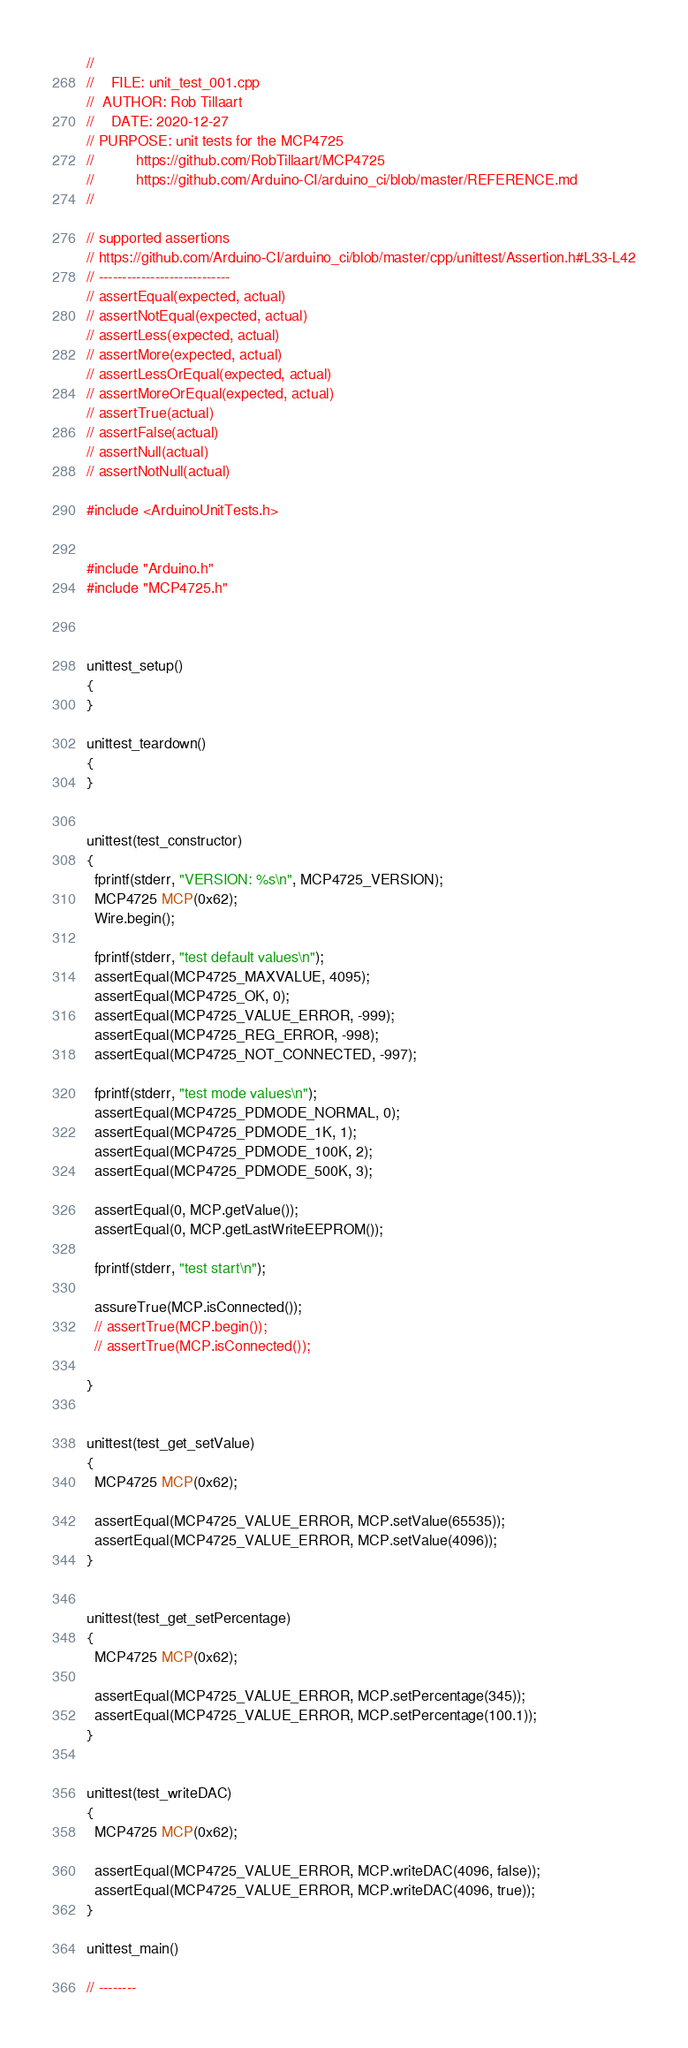Convert code to text. <code><loc_0><loc_0><loc_500><loc_500><_C++_>//
//    FILE: unit_test_001.cpp
//  AUTHOR: Rob Tillaart
//    DATE: 2020-12-27
// PURPOSE: unit tests for the MCP4725
//          https://github.com/RobTillaart/MCP4725
//          https://github.com/Arduino-CI/arduino_ci/blob/master/REFERENCE.md
//

// supported assertions
// https://github.com/Arduino-CI/arduino_ci/blob/master/cpp/unittest/Assertion.h#L33-L42
// ----------------------------
// assertEqual(expected, actual)
// assertNotEqual(expected, actual)
// assertLess(expected, actual)
// assertMore(expected, actual)
// assertLessOrEqual(expected, actual)
// assertMoreOrEqual(expected, actual)
// assertTrue(actual)
// assertFalse(actual)
// assertNull(actual)
// assertNotNull(actual)

#include <ArduinoUnitTests.h>


#include "Arduino.h"
#include "MCP4725.h"



unittest_setup()
{
}

unittest_teardown()
{
}


unittest(test_constructor)
{
  fprintf(stderr, "VERSION: %s\n", MCP4725_VERSION);
  MCP4725 MCP(0x62);
  Wire.begin();

  fprintf(stderr, "test default values\n");
  assertEqual(MCP4725_MAXVALUE, 4095);
  assertEqual(MCP4725_OK, 0);
  assertEqual(MCP4725_VALUE_ERROR, -999);
  assertEqual(MCP4725_REG_ERROR, -998);
  assertEqual(MCP4725_NOT_CONNECTED, -997);

  fprintf(stderr, "test mode values\n");
  assertEqual(MCP4725_PDMODE_NORMAL, 0);
  assertEqual(MCP4725_PDMODE_1K, 1);
  assertEqual(MCP4725_PDMODE_100K, 2);
  assertEqual(MCP4725_PDMODE_500K, 3);

  assertEqual(0, MCP.getValue());
  assertEqual(0, MCP.getLastWriteEEPROM());

  fprintf(stderr, "test start\n");

  assureTrue(MCP.isConnected());
  // assertTrue(MCP.begin());
  // assertTrue(MCP.isConnected());

}


unittest(test_get_setValue)
{
  MCP4725 MCP(0x62);

  assertEqual(MCP4725_VALUE_ERROR, MCP.setValue(65535));
  assertEqual(MCP4725_VALUE_ERROR, MCP.setValue(4096));
}


unittest(test_get_setPercentage)
{
  MCP4725 MCP(0x62);

  assertEqual(MCP4725_VALUE_ERROR, MCP.setPercentage(345));
  assertEqual(MCP4725_VALUE_ERROR, MCP.setPercentage(100.1));
}


unittest(test_writeDAC)
{
  MCP4725 MCP(0x62);

  assertEqual(MCP4725_VALUE_ERROR, MCP.writeDAC(4096, false));
  assertEqual(MCP4725_VALUE_ERROR, MCP.writeDAC(4096, true));
}

unittest_main()

// --------
</code> 